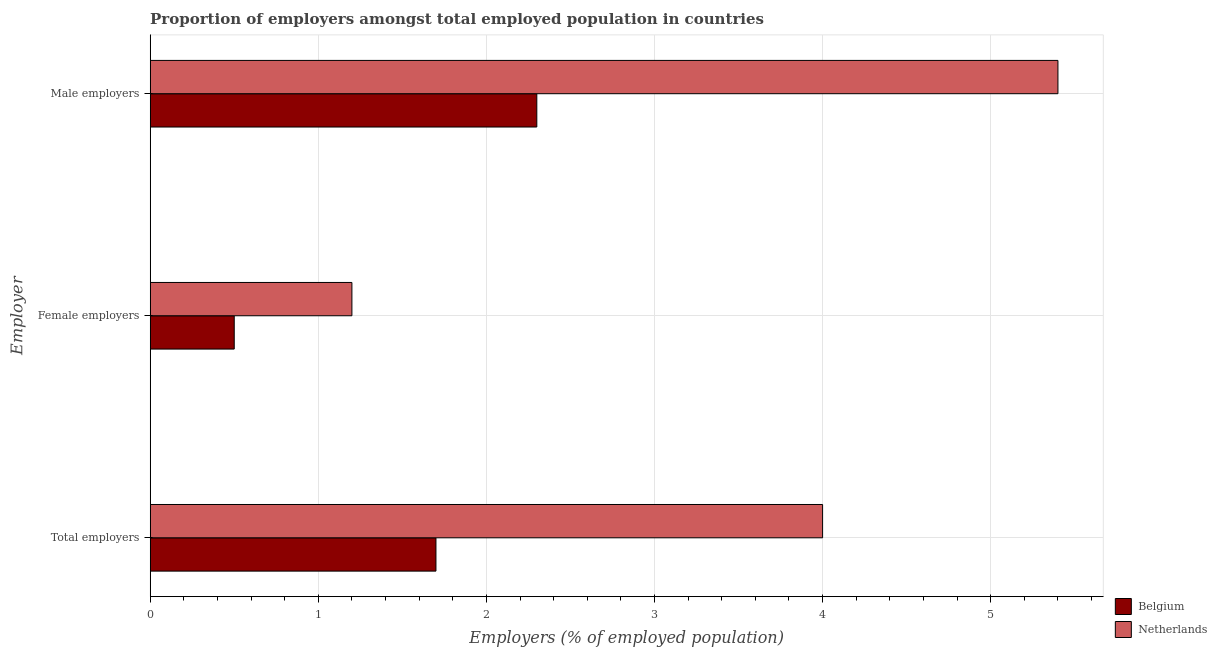How many bars are there on the 2nd tick from the top?
Your answer should be compact. 2. How many bars are there on the 3rd tick from the bottom?
Your answer should be compact. 2. What is the label of the 1st group of bars from the top?
Your response must be concise. Male employers. What is the percentage of total employers in Netherlands?
Your answer should be very brief. 4. Across all countries, what is the maximum percentage of female employers?
Offer a very short reply. 1.2. Across all countries, what is the minimum percentage of total employers?
Your answer should be compact. 1.7. In which country was the percentage of male employers maximum?
Keep it short and to the point. Netherlands. In which country was the percentage of female employers minimum?
Provide a succinct answer. Belgium. What is the total percentage of male employers in the graph?
Give a very brief answer. 7.7. What is the difference between the percentage of female employers in Belgium and that in Netherlands?
Your answer should be compact. -0.7. What is the difference between the percentage of male employers in Belgium and the percentage of female employers in Netherlands?
Provide a short and direct response. 1.1. What is the average percentage of female employers per country?
Keep it short and to the point. 0.85. What is the difference between the percentage of total employers and percentage of male employers in Belgium?
Make the answer very short. -0.6. In how many countries, is the percentage of female employers greater than 2.8 %?
Provide a short and direct response. 0. What is the ratio of the percentage of male employers in Netherlands to that in Belgium?
Offer a very short reply. 2.35. What is the difference between the highest and the second highest percentage of female employers?
Your answer should be very brief. 0.7. What is the difference between the highest and the lowest percentage of female employers?
Your response must be concise. 0.7. In how many countries, is the percentage of male employers greater than the average percentage of male employers taken over all countries?
Make the answer very short. 1. What does the 1st bar from the bottom in Male employers represents?
Ensure brevity in your answer.  Belgium. How many bars are there?
Your answer should be very brief. 6. Are all the bars in the graph horizontal?
Keep it short and to the point. Yes. How many countries are there in the graph?
Your response must be concise. 2. Are the values on the major ticks of X-axis written in scientific E-notation?
Offer a very short reply. No. Does the graph contain any zero values?
Provide a succinct answer. No. Does the graph contain grids?
Keep it short and to the point. Yes. Where does the legend appear in the graph?
Make the answer very short. Bottom right. What is the title of the graph?
Make the answer very short. Proportion of employers amongst total employed population in countries. What is the label or title of the X-axis?
Your answer should be very brief. Employers (% of employed population). What is the label or title of the Y-axis?
Keep it short and to the point. Employer. What is the Employers (% of employed population) of Belgium in Total employers?
Offer a terse response. 1.7. What is the Employers (% of employed population) of Belgium in Female employers?
Provide a succinct answer. 0.5. What is the Employers (% of employed population) in Netherlands in Female employers?
Give a very brief answer. 1.2. What is the Employers (% of employed population) in Belgium in Male employers?
Make the answer very short. 2.3. What is the Employers (% of employed population) in Netherlands in Male employers?
Make the answer very short. 5.4. Across all Employer, what is the maximum Employers (% of employed population) of Belgium?
Give a very brief answer. 2.3. Across all Employer, what is the maximum Employers (% of employed population) of Netherlands?
Provide a short and direct response. 5.4. Across all Employer, what is the minimum Employers (% of employed population) in Belgium?
Your answer should be compact. 0.5. Across all Employer, what is the minimum Employers (% of employed population) of Netherlands?
Your response must be concise. 1.2. What is the total Employers (% of employed population) of Belgium in the graph?
Keep it short and to the point. 4.5. What is the total Employers (% of employed population) of Netherlands in the graph?
Keep it short and to the point. 10.6. What is the difference between the Employers (% of employed population) in Belgium in Total employers and that in Female employers?
Offer a very short reply. 1.2. What is the difference between the Employers (% of employed population) of Belgium in Female employers and that in Male employers?
Your answer should be very brief. -1.8. What is the average Employers (% of employed population) in Netherlands per Employer?
Your response must be concise. 3.53. What is the difference between the Employers (% of employed population) of Belgium and Employers (% of employed population) of Netherlands in Total employers?
Give a very brief answer. -2.3. What is the difference between the Employers (% of employed population) in Belgium and Employers (% of employed population) in Netherlands in Female employers?
Offer a very short reply. -0.7. What is the ratio of the Employers (% of employed population) in Belgium in Total employers to that in Male employers?
Your answer should be compact. 0.74. What is the ratio of the Employers (% of employed population) in Netherlands in Total employers to that in Male employers?
Your answer should be very brief. 0.74. What is the ratio of the Employers (% of employed population) in Belgium in Female employers to that in Male employers?
Your answer should be very brief. 0.22. What is the ratio of the Employers (% of employed population) in Netherlands in Female employers to that in Male employers?
Provide a short and direct response. 0.22. What is the difference between the highest and the second highest Employers (% of employed population) of Netherlands?
Ensure brevity in your answer.  1.4. What is the difference between the highest and the lowest Employers (% of employed population) in Netherlands?
Offer a terse response. 4.2. 